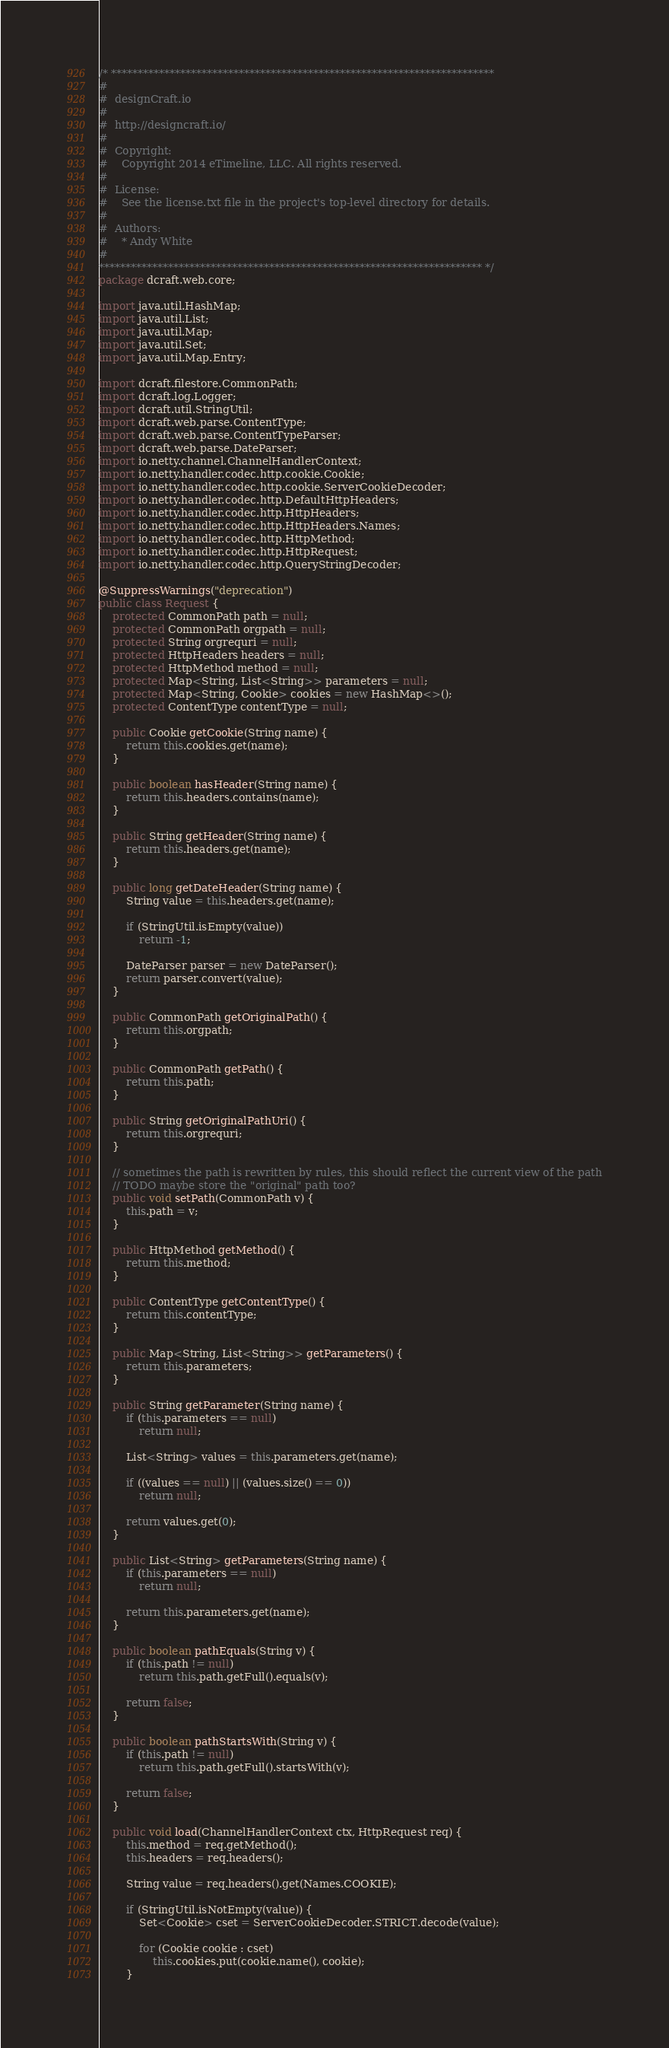Convert code to text. <code><loc_0><loc_0><loc_500><loc_500><_Java_>/* ************************************************************************
#
#  designCraft.io
#
#  http://designcraft.io/
#
#  Copyright:
#    Copyright 2014 eTimeline, LLC. All rights reserved.
#
#  License:
#    See the license.txt file in the project's top-level directory for details.
#
#  Authors:
#    * Andy White
#
************************************************************************ */
package dcraft.web.core;

import java.util.HashMap;
import java.util.List;
import java.util.Map;
import java.util.Set;
import java.util.Map.Entry;

import dcraft.filestore.CommonPath;
import dcraft.log.Logger;
import dcraft.util.StringUtil;
import dcraft.web.parse.ContentType;
import dcraft.web.parse.ContentTypeParser;
import dcraft.web.parse.DateParser;
import io.netty.channel.ChannelHandlerContext;
import io.netty.handler.codec.http.cookie.Cookie;
import io.netty.handler.codec.http.cookie.ServerCookieDecoder;
import io.netty.handler.codec.http.DefaultHttpHeaders;
import io.netty.handler.codec.http.HttpHeaders;
import io.netty.handler.codec.http.HttpHeaders.Names;
import io.netty.handler.codec.http.HttpMethod;
import io.netty.handler.codec.http.HttpRequest;
import io.netty.handler.codec.http.QueryStringDecoder;

@SuppressWarnings("deprecation")
public class Request {
	protected CommonPath path = null;
	protected CommonPath orgpath = null;
	protected String orgrequri = null;
	protected HttpHeaders headers = null;
	protected HttpMethod method = null;
	protected Map<String, List<String>> parameters = null;
    protected Map<String, Cookie> cookies = new HashMap<>();
	protected ContentType contentType = null;
	
    public Cookie getCookie(String name) {
    	return this.cookies.get(name);
    }

	public boolean hasHeader(String name) {
		return this.headers.contains(name);
	}
	
    public String getHeader(String name) {
    	return this.headers.get(name);
    }
    
    public long getDateHeader(String name) {
    	String value = this.headers.get(name);
    	
    	if (StringUtil.isEmpty(value))
    		return -1;
    	
    	DateParser parser = new DateParser();
    	return parser.convert(value);
    }
    
    public CommonPath getOriginalPath() {
		return this.orgpath;
	}
    
    public CommonPath getPath() {
		return this.path;
	}
    
    public String getOriginalPathUri() {
		return this.orgrequri;
	}
    
    // sometimes the path is rewritten by rules, this should reflect the current view of the path
    // TODO maybe store the "original" path too?
    public void setPath(CommonPath v) {
    	this.path = v;
    }
    
    public HttpMethod getMethod() {
		return this.method;
	}
    
    public ContentType getContentType() {
		return this.contentType;
	}
    
    public Map<String, List<String>> getParameters() {
    	return this.parameters;
    }
    
    public String getParameter(String name) {
    	if (this.parameters == null)
    		return null;
    	
    	List<String> values = this.parameters.get(name);
    	
    	if ((values == null) || (values.size() == 0))
    		return null;
    	
    	return values.get(0);
    }
	
    public List<String> getParameters(String name) {
    	if (this.parameters == null)
    		return null;
    	
    	return this.parameters.get(name);
    }
    
    public boolean pathEquals(String v) {
    	if (this.path != null)
    		return this.path.getFull().equals(v);
    	
    	return false;
    }
	
    public boolean pathStartsWith(String v) {
    	if (this.path != null)
    		return this.path.getFull().startsWith(v);
    	
    	return false;
    }
    
	public void load(ChannelHandlerContext ctx, HttpRequest req) {
		this.method = req.getMethod();
		this.headers = req.headers();
		
        String value = req.headers().get(Names.COOKIE);

        if (StringUtil.isNotEmpty(value)) {
        	Set<Cookie> cset = ServerCookieDecoder.STRICT.decode(value);
        	
        	for (Cookie cookie : cset) 
        		this.cookies.put(cookie.name(), cookie);
        }</code> 